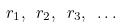Convert formula to latex. <formula><loc_0><loc_0><loc_500><loc_500>\ r _ { 1 } , \ r _ { 2 } , \ r _ { 3 } , \ \dots</formula> 